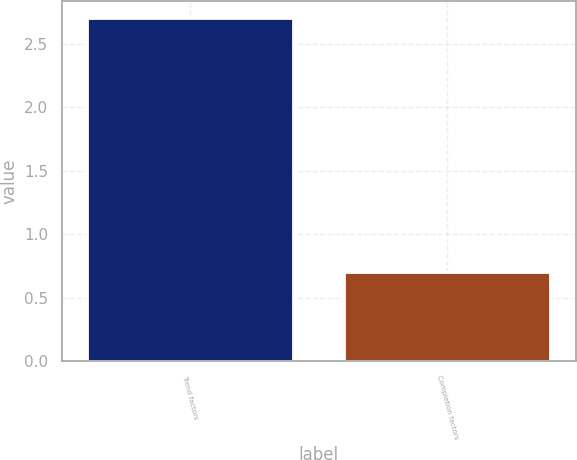<chart> <loc_0><loc_0><loc_500><loc_500><bar_chart><fcel>Trend factors<fcel>Completion factors<nl><fcel>2.7<fcel>0.7<nl></chart> 